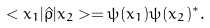<formula> <loc_0><loc_0><loc_500><loc_500>< x _ { 1 } | \hat { \rho } | x _ { 2 } > = \psi ( x _ { 1 } ) \psi ( x _ { 2 } ) ^ { * } .</formula> 